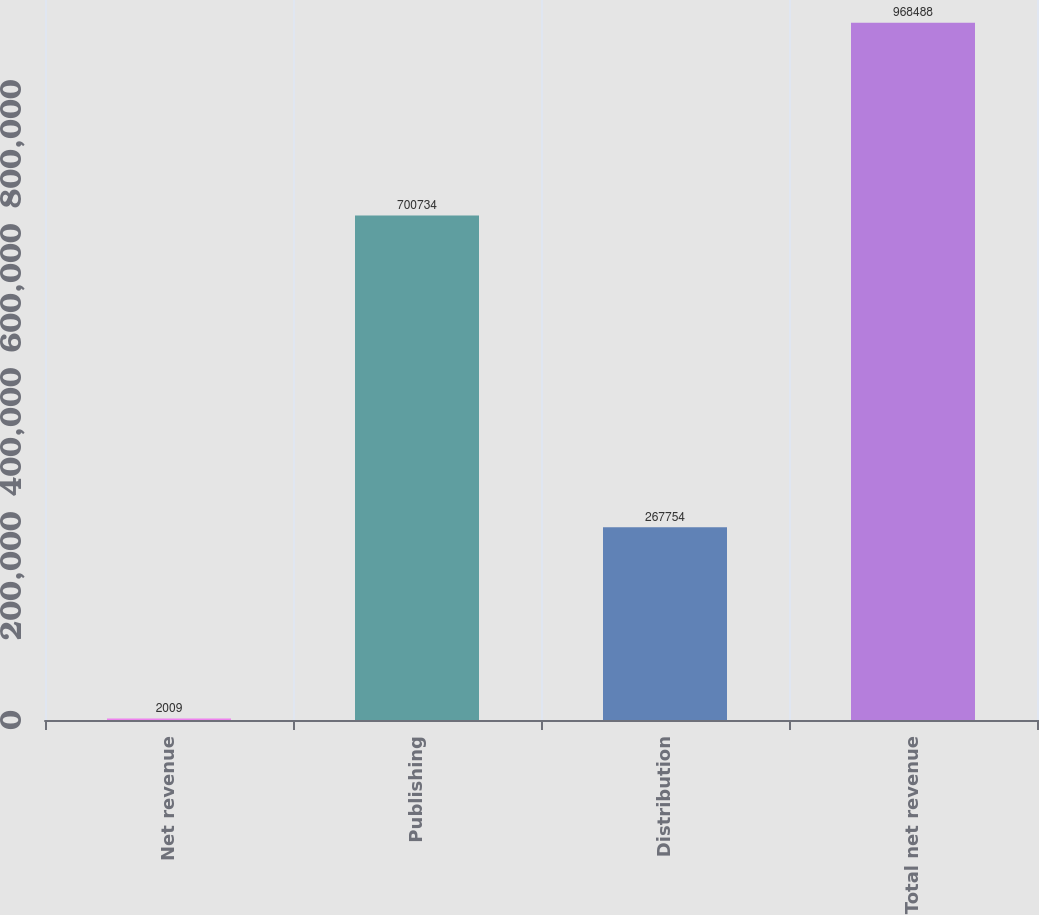Convert chart to OTSL. <chart><loc_0><loc_0><loc_500><loc_500><bar_chart><fcel>Net revenue<fcel>Publishing<fcel>Distribution<fcel>Total net revenue<nl><fcel>2009<fcel>700734<fcel>267754<fcel>968488<nl></chart> 